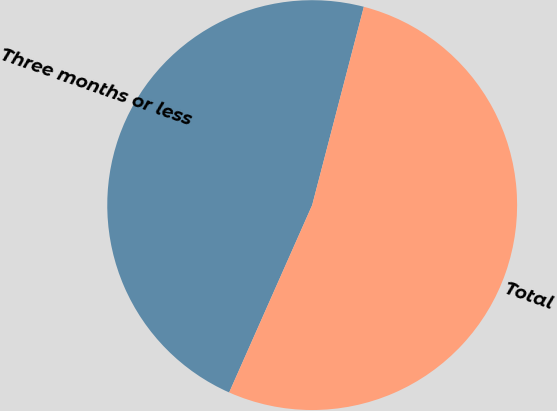<chart> <loc_0><loc_0><loc_500><loc_500><pie_chart><fcel>Three months or less<fcel>Total<nl><fcel>47.42%<fcel>52.58%<nl></chart> 